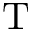Convert formula to latex. <formula><loc_0><loc_0><loc_500><loc_500>T</formula> 